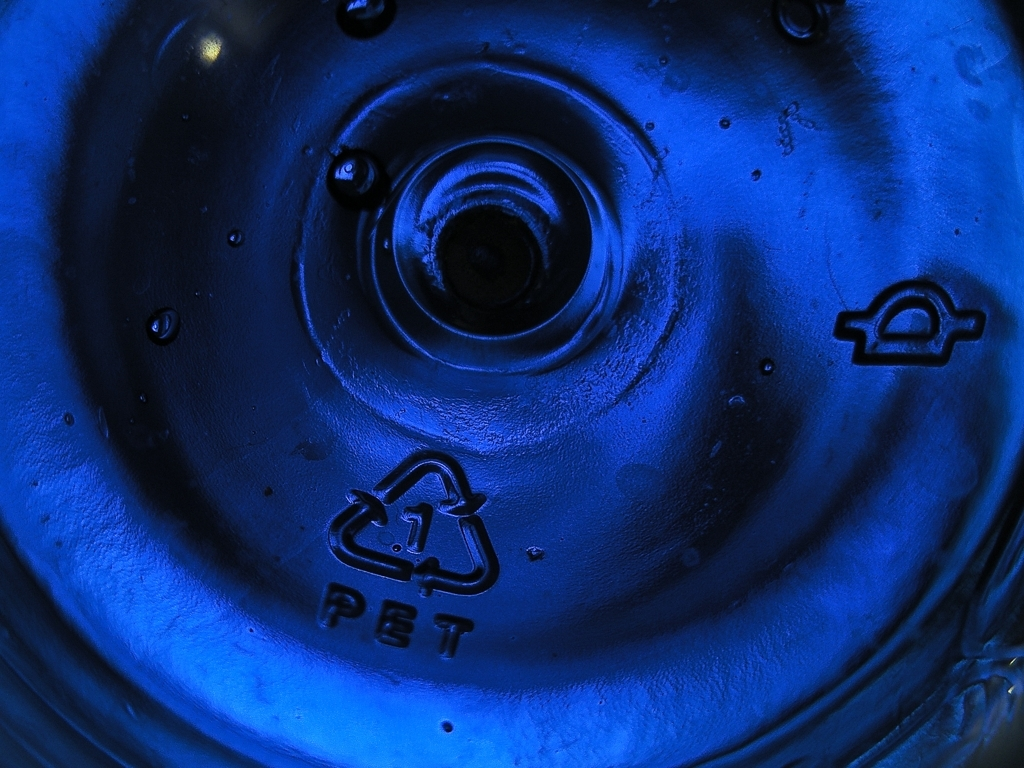What does the recycling symbol in the image indicate? The recycling symbol, indicated by three chasing arrows forming a triangle, denotes that the material is recyclable. The number inside the triangle ('1') represents the resin identification code for PET, helping to classify the type of plastic for recycling processes. 